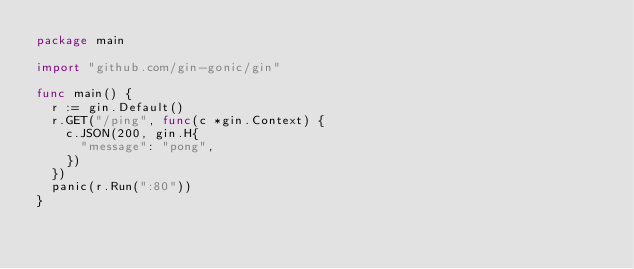Convert code to text. <code><loc_0><loc_0><loc_500><loc_500><_Go_>package main

import "github.com/gin-gonic/gin"

func main() {
	r := gin.Default()
	r.GET("/ping", func(c *gin.Context) {
		c.JSON(200, gin.H{
			"message": "pong",
		})
	})
	panic(r.Run(":80"))
}
</code> 